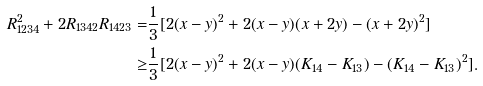Convert formula to latex. <formula><loc_0><loc_0><loc_500><loc_500>R _ { 1 2 3 4 } ^ { 2 } + 2 R _ { 1 3 4 2 } R _ { 1 4 2 3 } = & \frac { 1 } { 3 } [ 2 ( x - y ) ^ { 2 } + 2 ( x - y ) ( x + 2 y ) - ( x + 2 y ) ^ { 2 } ] \\ \geq & \frac { 1 } { 3 } [ 2 ( x - y ) ^ { 2 } + 2 ( x - y ) ( K _ { 1 4 } - K _ { 1 3 } ) - ( K _ { 1 4 } - K _ { 1 3 } ) ^ { 2 } ] . \\</formula> 